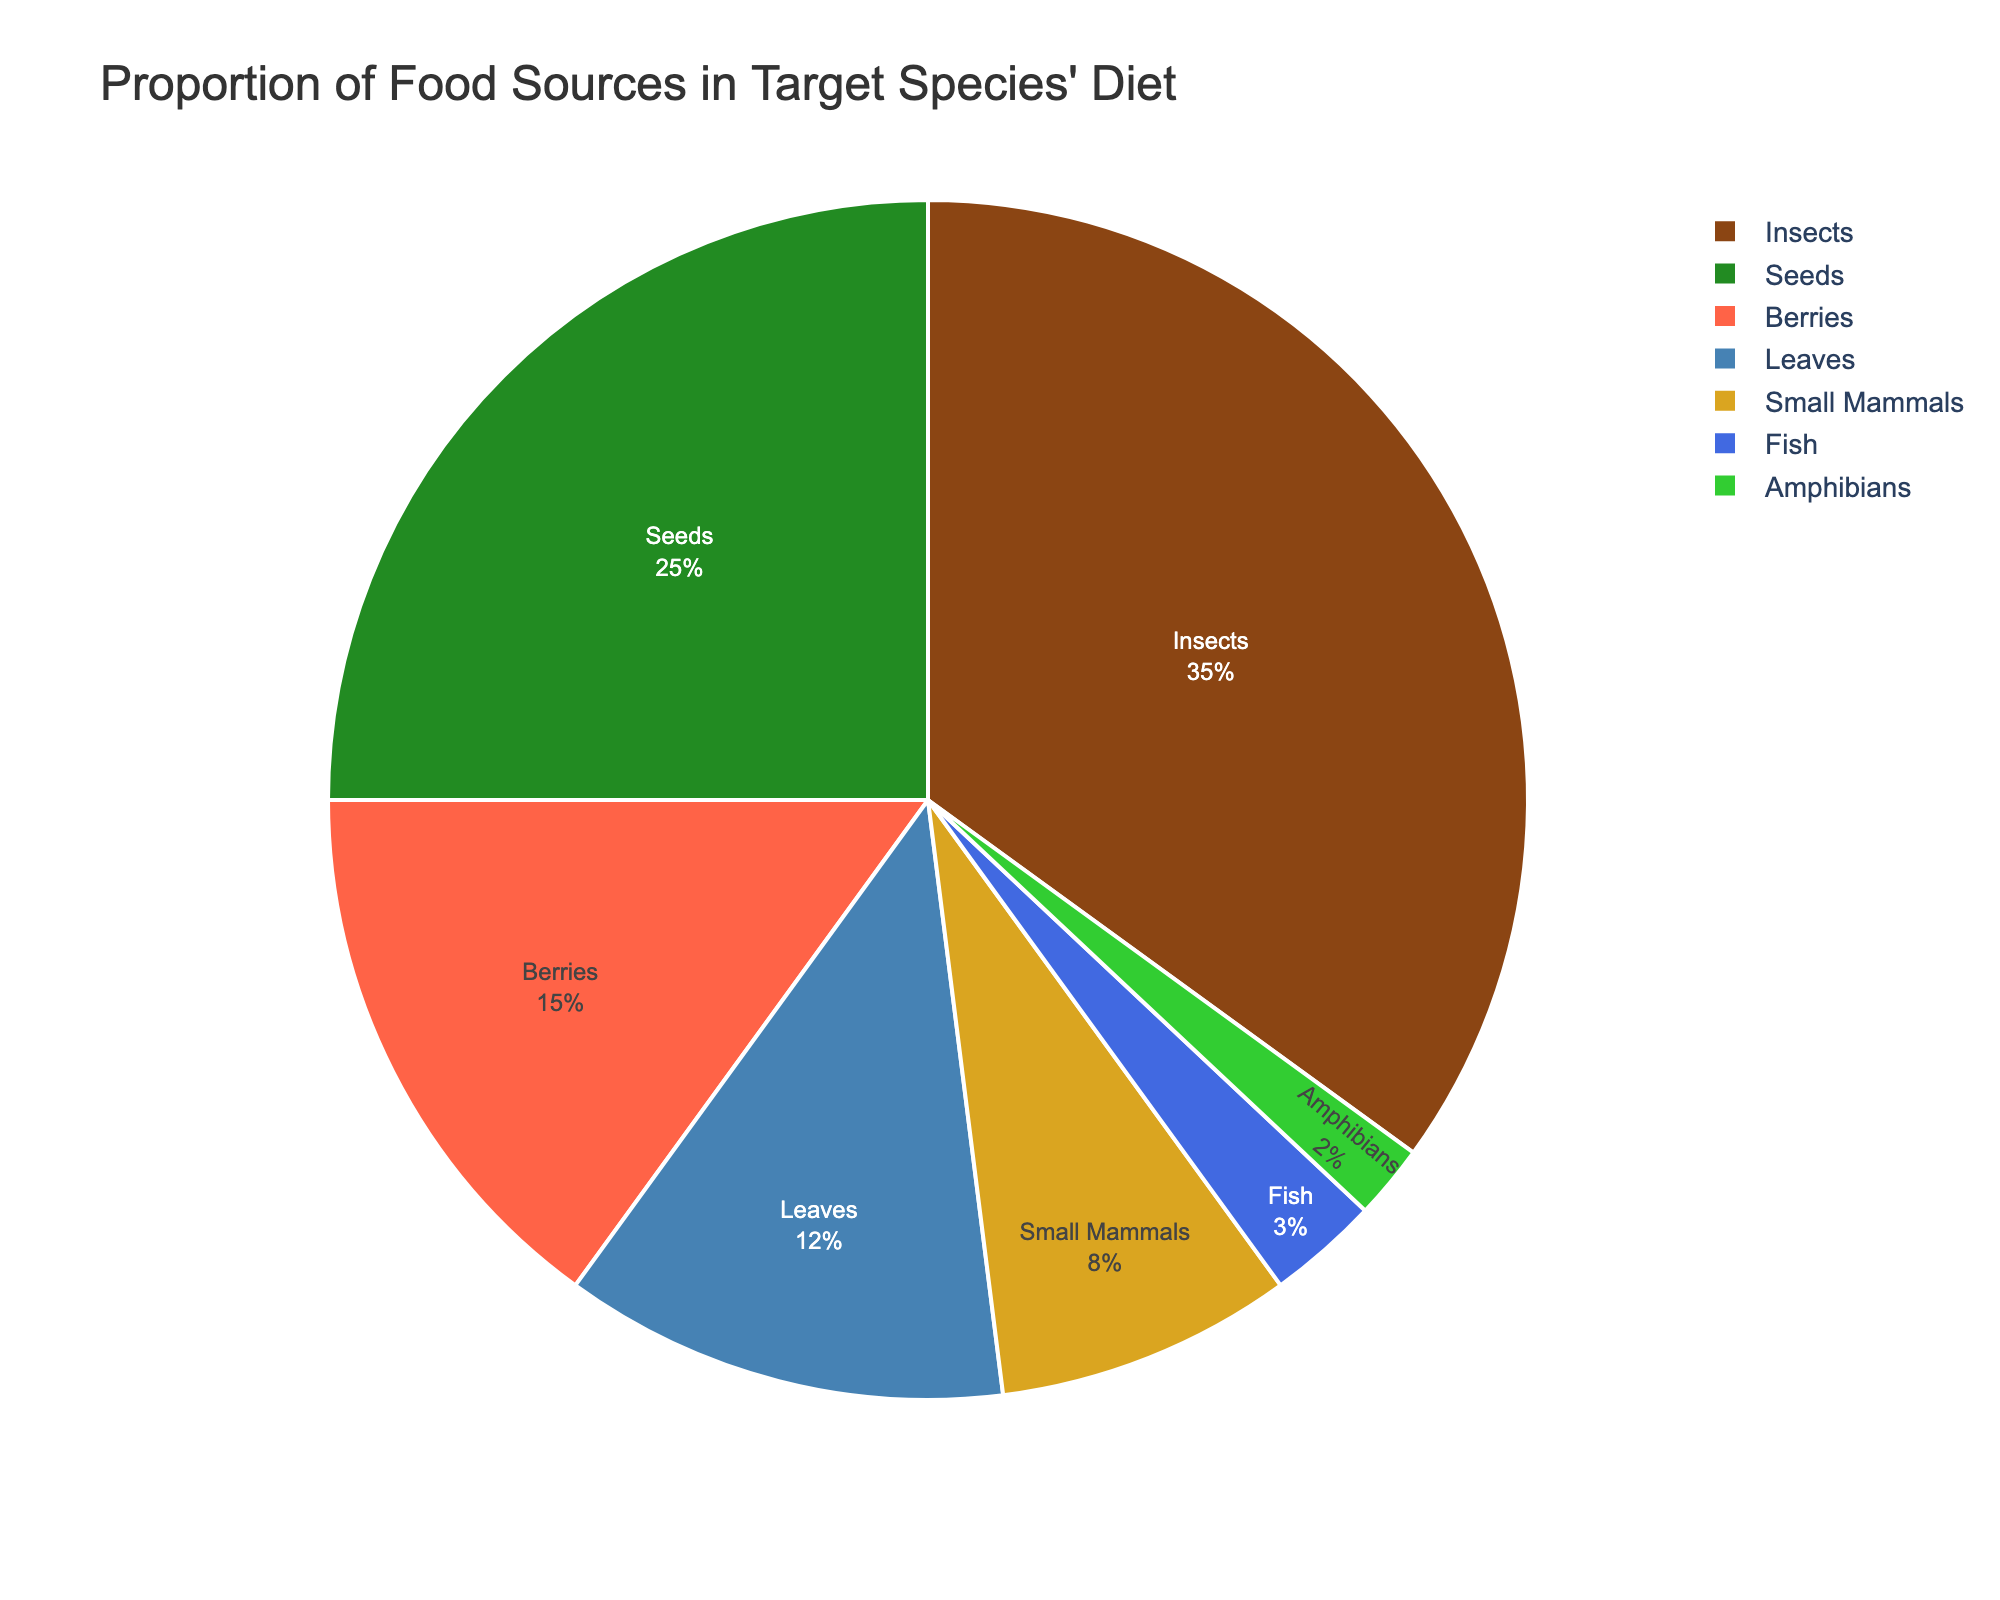What percentage of the target species' diet is made up of insects and seeds combined? The percentage of insects in the diet is 35%, and the percentage of seeds is 25%. Adding these together, 35% + 25% = 60%.
Answer: 60% Which food source makes up the smallest proportion of the target species' diet? The food sources and their corresponding percentages are: amphibians (2%), fish (3%), small mammals (8%), leaves (12%), berries (15%), seeds (25%), and insects (35%). The smallest proportion is amphibians at 2%.
Answer: Amphibians Do insects or berries constitute a larger portion of the diet, and by how much? Insects constitute 35% of the diet, and berries constitute 15% of the diet. The difference is 35% - 15% = 20%.
Answer: Insects by 20% What is the total percentage of the target species' diet that consists of plant-based food sources (seeds, berries, leaves)? The percentages of the plant-based food sources are: seeds (25%), berries (15%), and leaves (12%). Summing these up, 25% + 15% + 12% = 52%.
Answer: 52% Which portion of the pie chart is colored green, and what percentage does it represent? The custom color palette used has green color corresponding to seeds. Therefore, the green portion represents seeds, with a percentage of 25%.
Answer: Seeds, 25% Is the combined percentage of fish and amphibians more or less than the percentage of leaves, and by how much? The percentage of fish in the diet is 3% and amphibians is 2%. Combined, fish and amphibians make up 3% + 2% = 5%. Leaves make up 12%. So, 5% is less than 12% by 12% - 5% = 7%.
Answer: Less by 7% What is the most prominent food source in the target species' diet? The food sources and their respective percentages are: insects (35%), seeds (25%), berries (15%), leaves (12%), small mammals (8%), fish (3%), and amphibians (2%). The highest percentage is for insects at 35%.
Answer: Insects What percentage of the target species' diet consists of animal-based food sources (insects, small mammals, fish, amphibians)? The percentages of the animal-based food sources are: insects (35%), small mammals (8%), fish (3%), and amphibians (2%). Summing these values, 35% + 8% + 3% + 2% = 48%.
Answer: 48% 